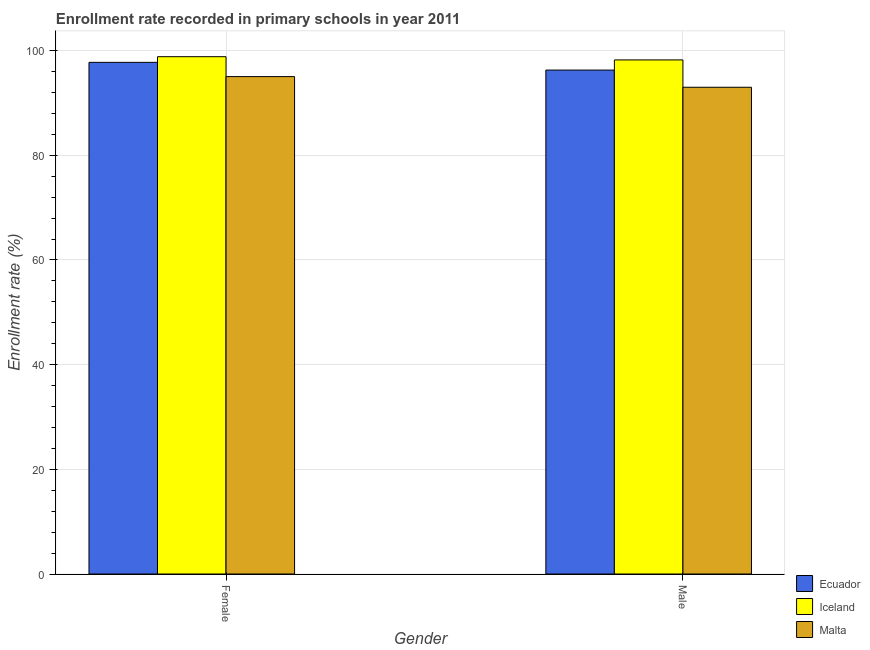How many bars are there on the 1st tick from the left?
Give a very brief answer. 3. What is the enrollment rate of female students in Malta?
Your answer should be very brief. 95.03. Across all countries, what is the maximum enrollment rate of male students?
Offer a very short reply. 98.22. Across all countries, what is the minimum enrollment rate of male students?
Your answer should be very brief. 93. In which country was the enrollment rate of male students maximum?
Offer a very short reply. Iceland. In which country was the enrollment rate of male students minimum?
Offer a terse response. Malta. What is the total enrollment rate of male students in the graph?
Your answer should be very brief. 287.5. What is the difference between the enrollment rate of male students in Iceland and that in Ecuador?
Make the answer very short. 1.94. What is the difference between the enrollment rate of female students in Iceland and the enrollment rate of male students in Ecuador?
Your answer should be compact. 2.56. What is the average enrollment rate of male students per country?
Make the answer very short. 95.83. What is the difference between the enrollment rate of male students and enrollment rate of female students in Malta?
Your answer should be compact. -2.04. In how many countries, is the enrollment rate of female students greater than 60 %?
Offer a terse response. 3. What is the ratio of the enrollment rate of female students in Iceland to that in Malta?
Offer a very short reply. 1.04. In how many countries, is the enrollment rate of female students greater than the average enrollment rate of female students taken over all countries?
Your answer should be compact. 2. What does the 2nd bar from the left in Female represents?
Provide a short and direct response. Iceland. What does the 1st bar from the right in Female represents?
Your answer should be very brief. Malta. Are all the bars in the graph horizontal?
Provide a short and direct response. No. How many countries are there in the graph?
Give a very brief answer. 3. What is the difference between two consecutive major ticks on the Y-axis?
Your response must be concise. 20. Does the graph contain any zero values?
Your response must be concise. No. Where does the legend appear in the graph?
Your answer should be compact. Bottom right. How many legend labels are there?
Keep it short and to the point. 3. How are the legend labels stacked?
Your answer should be very brief. Vertical. What is the title of the graph?
Provide a succinct answer. Enrollment rate recorded in primary schools in year 2011. Does "Sweden" appear as one of the legend labels in the graph?
Ensure brevity in your answer.  No. What is the label or title of the X-axis?
Provide a short and direct response. Gender. What is the label or title of the Y-axis?
Your answer should be very brief. Enrollment rate (%). What is the Enrollment rate (%) of Ecuador in Female?
Offer a terse response. 97.76. What is the Enrollment rate (%) in Iceland in Female?
Your answer should be very brief. 98.84. What is the Enrollment rate (%) of Malta in Female?
Keep it short and to the point. 95.03. What is the Enrollment rate (%) of Ecuador in Male?
Your response must be concise. 96.28. What is the Enrollment rate (%) in Iceland in Male?
Give a very brief answer. 98.22. What is the Enrollment rate (%) of Malta in Male?
Your answer should be very brief. 93. Across all Gender, what is the maximum Enrollment rate (%) in Ecuador?
Your answer should be compact. 97.76. Across all Gender, what is the maximum Enrollment rate (%) in Iceland?
Your response must be concise. 98.84. Across all Gender, what is the maximum Enrollment rate (%) of Malta?
Provide a short and direct response. 95.03. Across all Gender, what is the minimum Enrollment rate (%) of Ecuador?
Offer a terse response. 96.28. Across all Gender, what is the minimum Enrollment rate (%) in Iceland?
Give a very brief answer. 98.22. Across all Gender, what is the minimum Enrollment rate (%) of Malta?
Give a very brief answer. 93. What is the total Enrollment rate (%) of Ecuador in the graph?
Provide a short and direct response. 194.03. What is the total Enrollment rate (%) in Iceland in the graph?
Keep it short and to the point. 197.06. What is the total Enrollment rate (%) of Malta in the graph?
Give a very brief answer. 188.03. What is the difference between the Enrollment rate (%) of Ecuador in Female and that in Male?
Ensure brevity in your answer.  1.48. What is the difference between the Enrollment rate (%) in Iceland in Female and that in Male?
Your response must be concise. 0.61. What is the difference between the Enrollment rate (%) in Malta in Female and that in Male?
Make the answer very short. 2.04. What is the difference between the Enrollment rate (%) of Ecuador in Female and the Enrollment rate (%) of Iceland in Male?
Give a very brief answer. -0.47. What is the difference between the Enrollment rate (%) of Ecuador in Female and the Enrollment rate (%) of Malta in Male?
Ensure brevity in your answer.  4.76. What is the difference between the Enrollment rate (%) of Iceland in Female and the Enrollment rate (%) of Malta in Male?
Offer a terse response. 5.84. What is the average Enrollment rate (%) in Ecuador per Gender?
Your answer should be very brief. 97.02. What is the average Enrollment rate (%) of Iceland per Gender?
Your answer should be very brief. 98.53. What is the average Enrollment rate (%) in Malta per Gender?
Your answer should be very brief. 94.01. What is the difference between the Enrollment rate (%) of Ecuador and Enrollment rate (%) of Iceland in Female?
Your response must be concise. -1.08. What is the difference between the Enrollment rate (%) in Ecuador and Enrollment rate (%) in Malta in Female?
Give a very brief answer. 2.72. What is the difference between the Enrollment rate (%) in Iceland and Enrollment rate (%) in Malta in Female?
Make the answer very short. 3.8. What is the difference between the Enrollment rate (%) in Ecuador and Enrollment rate (%) in Iceland in Male?
Offer a terse response. -1.94. What is the difference between the Enrollment rate (%) of Ecuador and Enrollment rate (%) of Malta in Male?
Ensure brevity in your answer.  3.28. What is the difference between the Enrollment rate (%) in Iceland and Enrollment rate (%) in Malta in Male?
Give a very brief answer. 5.22. What is the ratio of the Enrollment rate (%) of Ecuador in Female to that in Male?
Offer a terse response. 1.02. What is the ratio of the Enrollment rate (%) of Malta in Female to that in Male?
Make the answer very short. 1.02. What is the difference between the highest and the second highest Enrollment rate (%) in Ecuador?
Offer a very short reply. 1.48. What is the difference between the highest and the second highest Enrollment rate (%) in Iceland?
Ensure brevity in your answer.  0.61. What is the difference between the highest and the second highest Enrollment rate (%) of Malta?
Give a very brief answer. 2.04. What is the difference between the highest and the lowest Enrollment rate (%) in Ecuador?
Keep it short and to the point. 1.48. What is the difference between the highest and the lowest Enrollment rate (%) in Iceland?
Your answer should be very brief. 0.61. What is the difference between the highest and the lowest Enrollment rate (%) of Malta?
Provide a short and direct response. 2.04. 